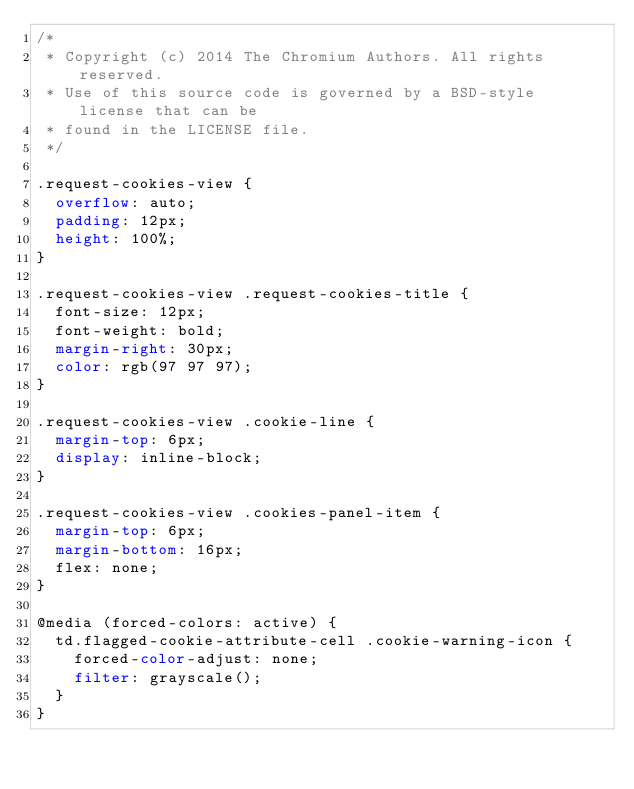<code> <loc_0><loc_0><loc_500><loc_500><_CSS_>/*
 * Copyright (c) 2014 The Chromium Authors. All rights reserved.
 * Use of this source code is governed by a BSD-style license that can be
 * found in the LICENSE file.
 */

.request-cookies-view {
  overflow: auto;
  padding: 12px;
  height: 100%;
}

.request-cookies-view .request-cookies-title {
  font-size: 12px;
  font-weight: bold;
  margin-right: 30px;
  color: rgb(97 97 97);
}

.request-cookies-view .cookie-line {
  margin-top: 6px;
  display: inline-block;
}

.request-cookies-view .cookies-panel-item {
  margin-top: 6px;
  margin-bottom: 16px;
  flex: none;
}

@media (forced-colors: active) {
  td.flagged-cookie-attribute-cell .cookie-warning-icon {
    forced-color-adjust: none;
    filter: grayscale();
  }
}
</code> 